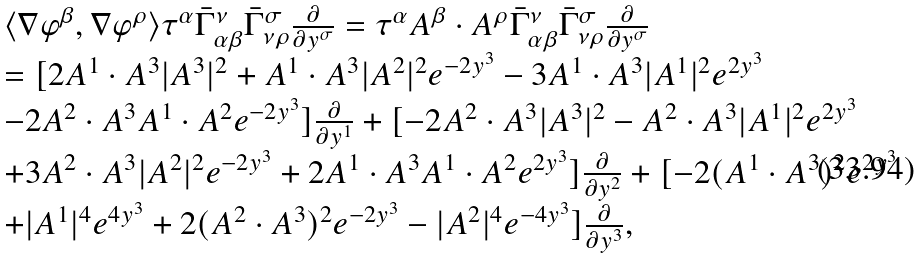<formula> <loc_0><loc_0><loc_500><loc_500>\begin{array} { l l l } \langle \nabla \varphi ^ { \beta } , \nabla \varphi ^ { \rho } \rangle \tau ^ { \alpha } { \bar { \Gamma } _ { \alpha \beta } ^ { \nu } } { \bar { \Gamma } _ { \nu \rho } ^ { \sigma } } \frac { \partial } { \partial y ^ { \sigma } } = \tau ^ { \alpha } A ^ { \beta } \cdot A ^ { \rho } { \bar { \Gamma } _ { \alpha \beta } ^ { \nu } } { \bar { \Gamma } _ { \nu \rho } ^ { \sigma } } \frac { \partial } { \partial y ^ { \sigma } } \\ = [ 2 A ^ { 1 } \cdot A ^ { 3 } | A ^ { 3 } | ^ { 2 } + A ^ { 1 } \cdot A ^ { 3 } | A ^ { 2 } | ^ { 2 } e ^ { - 2 y ^ { 3 } } - 3 A ^ { 1 } \cdot A ^ { 3 } | A ^ { 1 } | ^ { 2 } e ^ { 2 y ^ { 3 } } \\ - 2 A ^ { 2 } \cdot A ^ { 3 } A ^ { 1 } \cdot A ^ { 2 } e ^ { - 2 y ^ { 3 } } ] \frac { \partial } { \partial y ^ { 1 } } + [ - 2 A ^ { 2 } \cdot A ^ { 3 } | A ^ { 3 } | ^ { 2 } - A ^ { 2 } \cdot A ^ { 3 } | A ^ { 1 } | ^ { 2 } e ^ { 2 y ^ { 3 } } \\ + 3 A ^ { 2 } \cdot A ^ { 3 } | A ^ { 2 } | ^ { 2 } e ^ { - 2 y ^ { 3 } } + 2 A ^ { 1 } \cdot A ^ { 3 } A ^ { 1 } \cdot A ^ { 2 } e ^ { 2 y ^ { 3 } } ] \frac { \partial } { \partial y ^ { 2 } } + [ - 2 ( A ^ { 1 } \cdot A ^ { 3 } ) ^ { 2 } e ^ { 2 y ^ { 3 } } \\ + | A ^ { 1 } | ^ { 4 } e ^ { 4 y ^ { 3 } } + 2 ( A ^ { 2 } \cdot A ^ { 3 } ) ^ { 2 } e ^ { - 2 y ^ { 3 } } - | A ^ { 2 } | ^ { 4 } e ^ { - 4 y ^ { 3 } } ] \frac { \partial } { \partial y ^ { 3 } } , \end{array}</formula> 